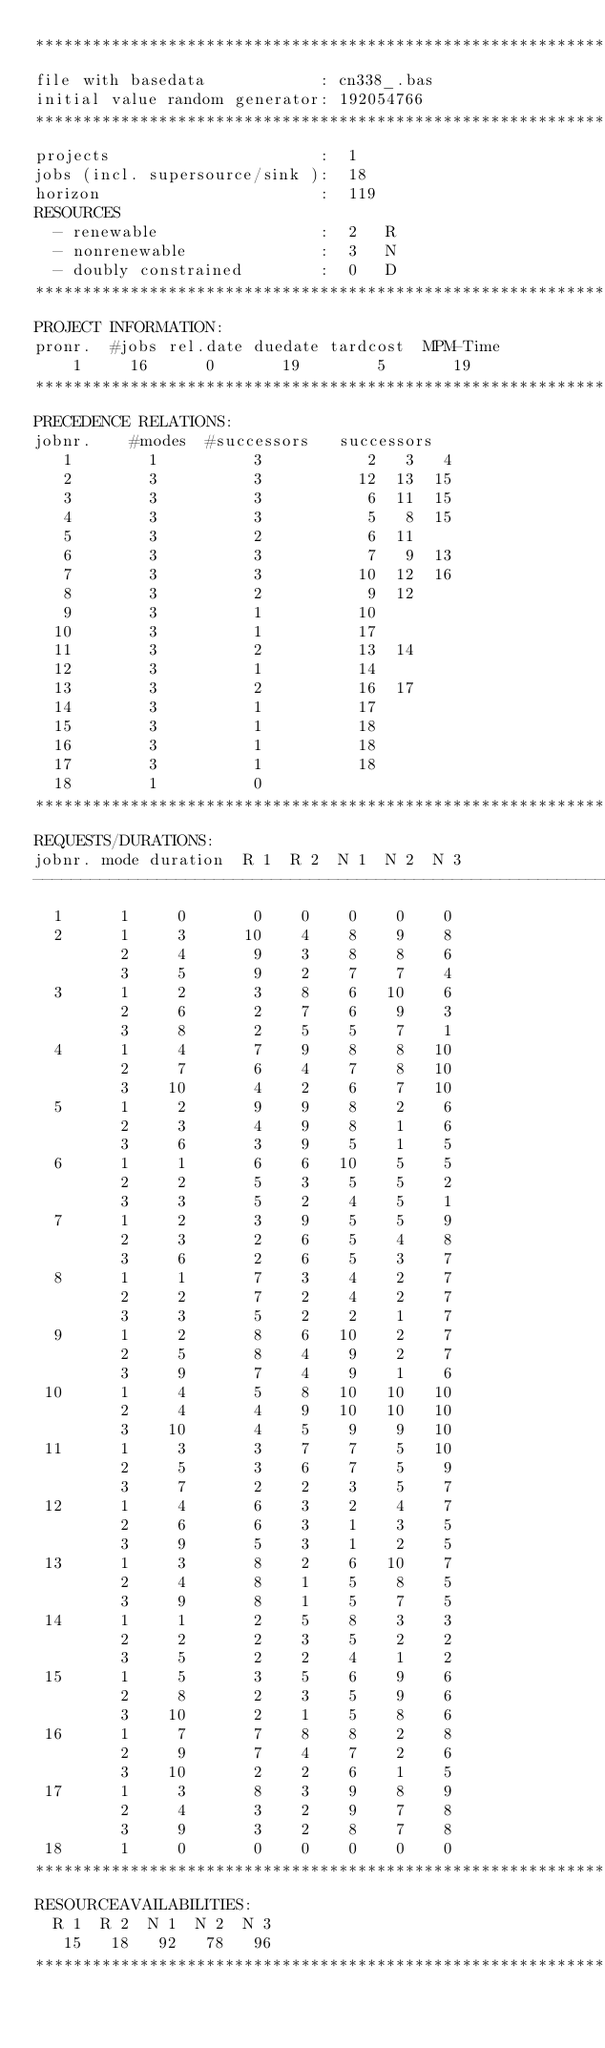Convert code to text. <code><loc_0><loc_0><loc_500><loc_500><_ObjectiveC_>************************************************************************
file with basedata            : cn338_.bas
initial value random generator: 192054766
************************************************************************
projects                      :  1
jobs (incl. supersource/sink ):  18
horizon                       :  119
RESOURCES
  - renewable                 :  2   R
  - nonrenewable              :  3   N
  - doubly constrained        :  0   D
************************************************************************
PROJECT INFORMATION:
pronr.  #jobs rel.date duedate tardcost  MPM-Time
    1     16      0       19        5       19
************************************************************************
PRECEDENCE RELATIONS:
jobnr.    #modes  #successors   successors
   1        1          3           2   3   4
   2        3          3          12  13  15
   3        3          3           6  11  15
   4        3          3           5   8  15
   5        3          2           6  11
   6        3          3           7   9  13
   7        3          3          10  12  16
   8        3          2           9  12
   9        3          1          10
  10        3          1          17
  11        3          2          13  14
  12        3          1          14
  13        3          2          16  17
  14        3          1          17
  15        3          1          18
  16        3          1          18
  17        3          1          18
  18        1          0        
************************************************************************
REQUESTS/DURATIONS:
jobnr. mode duration  R 1  R 2  N 1  N 2  N 3
------------------------------------------------------------------------
  1      1     0       0    0    0    0    0
  2      1     3      10    4    8    9    8
         2     4       9    3    8    8    6
         3     5       9    2    7    7    4
  3      1     2       3    8    6   10    6
         2     6       2    7    6    9    3
         3     8       2    5    5    7    1
  4      1     4       7    9    8    8   10
         2     7       6    4    7    8   10
         3    10       4    2    6    7   10
  5      1     2       9    9    8    2    6
         2     3       4    9    8    1    6
         3     6       3    9    5    1    5
  6      1     1       6    6   10    5    5
         2     2       5    3    5    5    2
         3     3       5    2    4    5    1
  7      1     2       3    9    5    5    9
         2     3       2    6    5    4    8
         3     6       2    6    5    3    7
  8      1     1       7    3    4    2    7
         2     2       7    2    4    2    7
         3     3       5    2    2    1    7
  9      1     2       8    6   10    2    7
         2     5       8    4    9    2    7
         3     9       7    4    9    1    6
 10      1     4       5    8   10   10   10
         2     4       4    9   10   10   10
         3    10       4    5    9    9   10
 11      1     3       3    7    7    5   10
         2     5       3    6    7    5    9
         3     7       2    2    3    5    7
 12      1     4       6    3    2    4    7
         2     6       6    3    1    3    5
         3     9       5    3    1    2    5
 13      1     3       8    2    6   10    7
         2     4       8    1    5    8    5
         3     9       8    1    5    7    5
 14      1     1       2    5    8    3    3
         2     2       2    3    5    2    2
         3     5       2    2    4    1    2
 15      1     5       3    5    6    9    6
         2     8       2    3    5    9    6
         3    10       2    1    5    8    6
 16      1     7       7    8    8    2    8
         2     9       7    4    7    2    6
         3    10       2    2    6    1    5
 17      1     3       8    3    9    8    9
         2     4       3    2    9    7    8
         3     9       3    2    8    7    8
 18      1     0       0    0    0    0    0
************************************************************************
RESOURCEAVAILABILITIES:
  R 1  R 2  N 1  N 2  N 3
   15   18   92   78   96
************************************************************************
</code> 